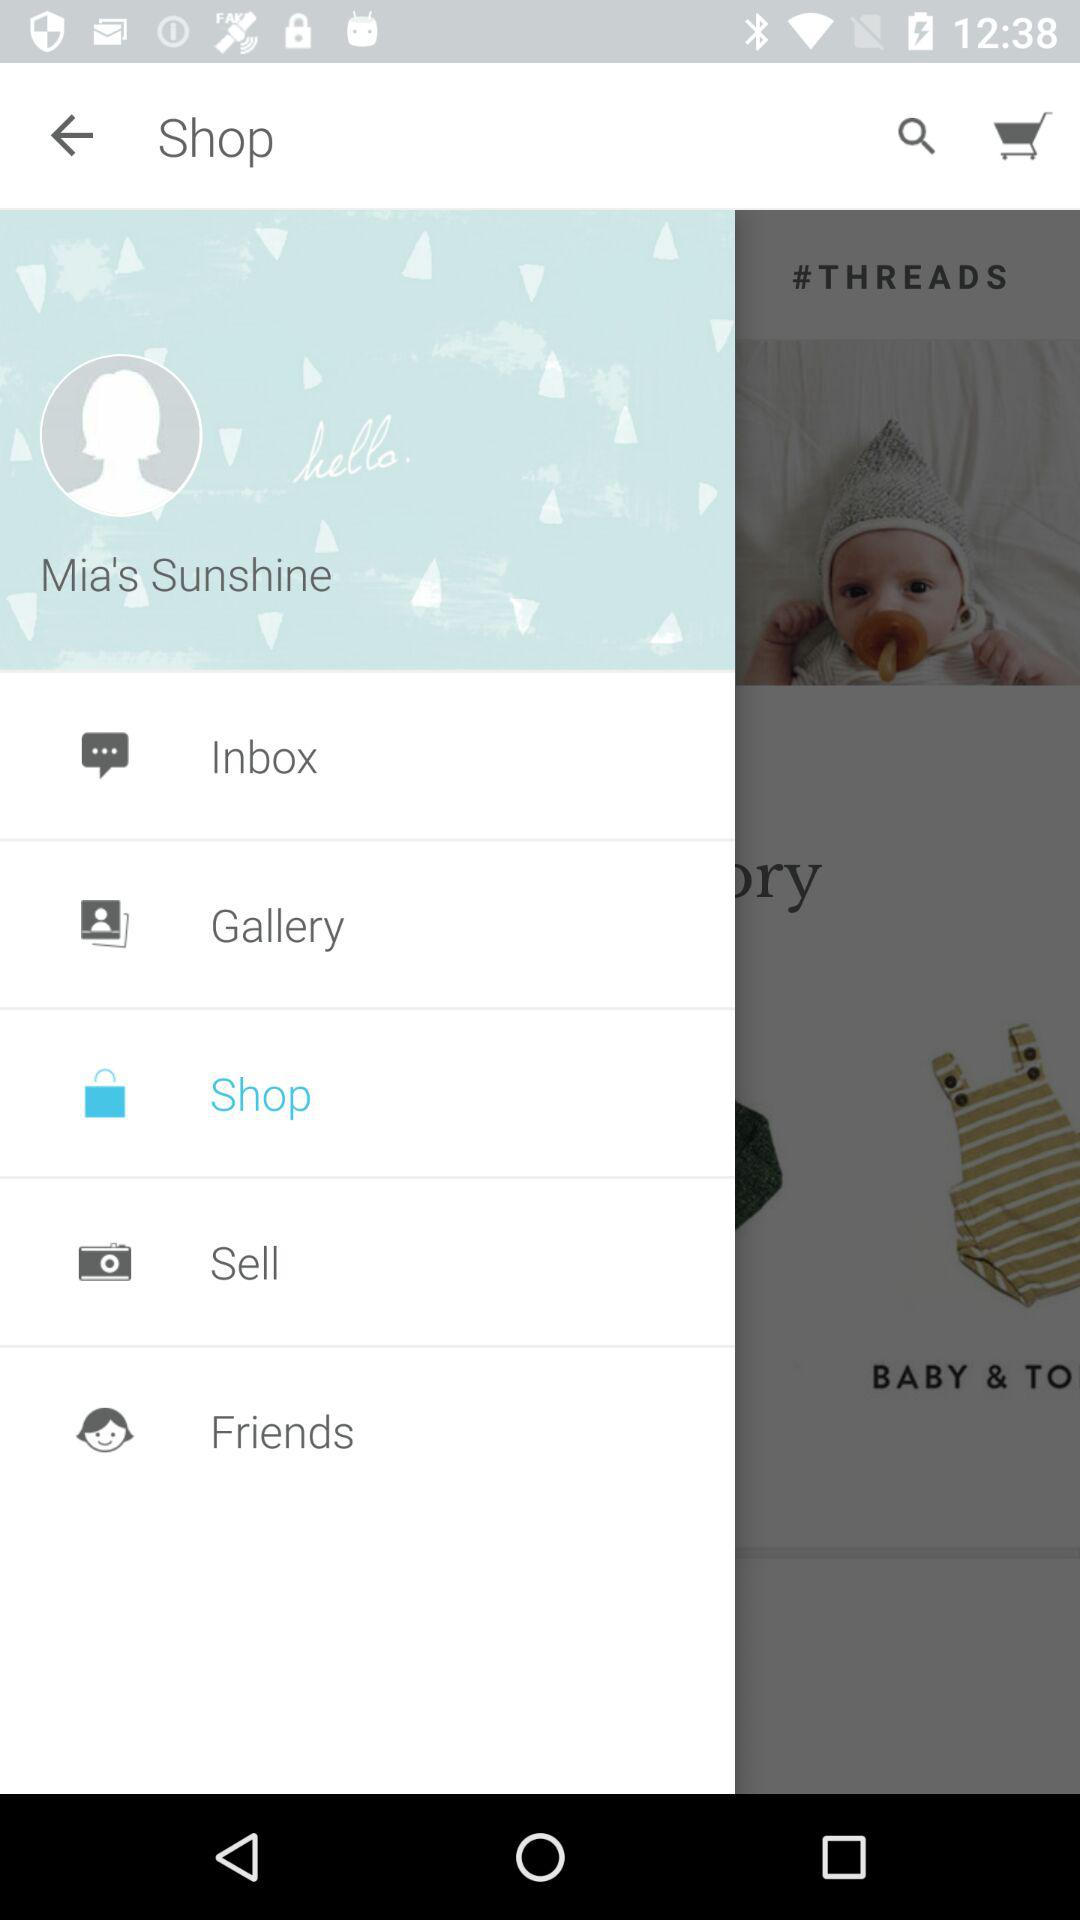What is the username? The username is "Mia's Sunshine". 